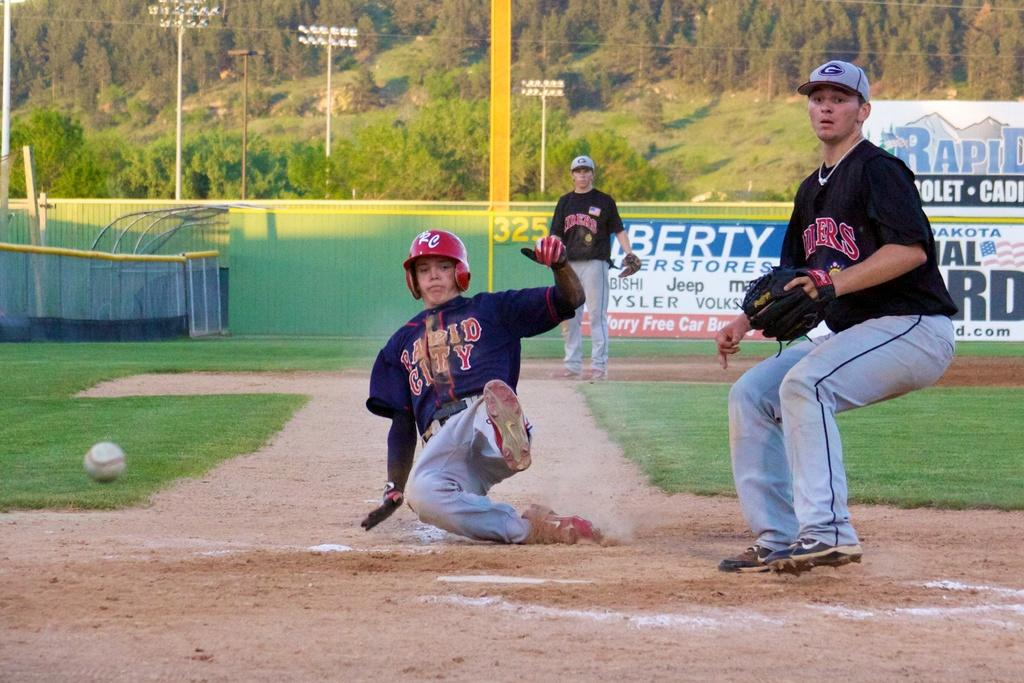<image>
Render a clear and concise summary of the photo. A Rapid City baseball player is sliding into home plate. 